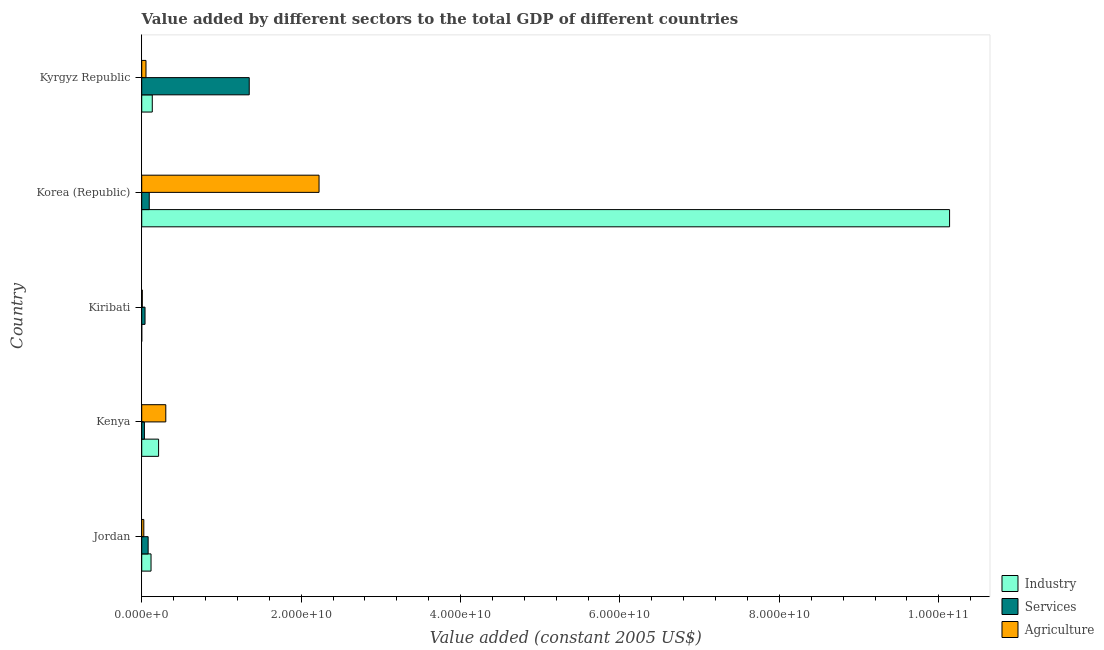How many different coloured bars are there?
Your answer should be compact. 3. How many groups of bars are there?
Keep it short and to the point. 5. How many bars are there on the 5th tick from the top?
Provide a short and direct response. 3. What is the label of the 2nd group of bars from the top?
Provide a short and direct response. Korea (Republic). What is the value added by industrial sector in Kiribati?
Your answer should be very brief. 3.87e+06. Across all countries, what is the maximum value added by industrial sector?
Offer a very short reply. 1.01e+11. Across all countries, what is the minimum value added by agricultural sector?
Give a very brief answer. 7.24e+07. In which country was the value added by industrial sector maximum?
Your answer should be compact. Korea (Republic). In which country was the value added by agricultural sector minimum?
Offer a very short reply. Kiribati. What is the total value added by industrial sector in the graph?
Offer a terse response. 1.06e+11. What is the difference between the value added by services in Kiribati and that in Kyrgyz Republic?
Provide a succinct answer. -1.31e+1. What is the difference between the value added by services in Korea (Republic) and the value added by industrial sector in Kiribati?
Offer a very short reply. 9.40e+08. What is the average value added by industrial sector per country?
Provide a succinct answer. 2.12e+1. What is the difference between the value added by services and value added by industrial sector in Kenya?
Offer a very short reply. -1.78e+09. In how many countries, is the value added by industrial sector greater than 52000000000 US$?
Your answer should be compact. 1. What is the ratio of the value added by services in Jordan to that in Kyrgyz Republic?
Ensure brevity in your answer.  0.06. What is the difference between the highest and the second highest value added by agricultural sector?
Your response must be concise. 1.92e+1. What is the difference between the highest and the lowest value added by industrial sector?
Keep it short and to the point. 1.01e+11. Is the sum of the value added by industrial sector in Korea (Republic) and Kyrgyz Republic greater than the maximum value added by services across all countries?
Your answer should be very brief. Yes. What does the 1st bar from the top in Jordan represents?
Make the answer very short. Agriculture. What does the 3rd bar from the bottom in Kiribati represents?
Provide a short and direct response. Agriculture. How many bars are there?
Give a very brief answer. 15. What is the difference between two consecutive major ticks on the X-axis?
Your response must be concise. 2.00e+1. Does the graph contain grids?
Make the answer very short. No. How are the legend labels stacked?
Give a very brief answer. Vertical. What is the title of the graph?
Offer a very short reply. Value added by different sectors to the total GDP of different countries. Does "Natural Gas" appear as one of the legend labels in the graph?
Give a very brief answer. No. What is the label or title of the X-axis?
Offer a terse response. Value added (constant 2005 US$). What is the label or title of the Y-axis?
Offer a terse response. Country. What is the Value added (constant 2005 US$) of Industry in Jordan?
Provide a succinct answer. 1.17e+09. What is the Value added (constant 2005 US$) of Services in Jordan?
Provide a succinct answer. 8.06e+08. What is the Value added (constant 2005 US$) of Agriculture in Jordan?
Make the answer very short. 2.62e+08. What is the Value added (constant 2005 US$) in Industry in Kenya?
Make the answer very short. 2.12e+09. What is the Value added (constant 2005 US$) in Services in Kenya?
Give a very brief answer. 3.37e+08. What is the Value added (constant 2005 US$) of Agriculture in Kenya?
Provide a succinct answer. 3.02e+09. What is the Value added (constant 2005 US$) of Industry in Kiribati?
Make the answer very short. 3.87e+06. What is the Value added (constant 2005 US$) in Services in Kiribati?
Provide a short and direct response. 4.15e+08. What is the Value added (constant 2005 US$) in Agriculture in Kiribati?
Offer a terse response. 7.24e+07. What is the Value added (constant 2005 US$) of Industry in Korea (Republic)?
Ensure brevity in your answer.  1.01e+11. What is the Value added (constant 2005 US$) of Services in Korea (Republic)?
Offer a terse response. 9.44e+08. What is the Value added (constant 2005 US$) of Agriculture in Korea (Republic)?
Make the answer very short. 2.22e+1. What is the Value added (constant 2005 US$) of Industry in Kyrgyz Republic?
Make the answer very short. 1.32e+09. What is the Value added (constant 2005 US$) in Services in Kyrgyz Republic?
Your response must be concise. 1.35e+1. What is the Value added (constant 2005 US$) in Agriculture in Kyrgyz Republic?
Ensure brevity in your answer.  5.34e+08. Across all countries, what is the maximum Value added (constant 2005 US$) in Industry?
Ensure brevity in your answer.  1.01e+11. Across all countries, what is the maximum Value added (constant 2005 US$) of Services?
Ensure brevity in your answer.  1.35e+1. Across all countries, what is the maximum Value added (constant 2005 US$) in Agriculture?
Your response must be concise. 2.22e+1. Across all countries, what is the minimum Value added (constant 2005 US$) of Industry?
Your response must be concise. 3.87e+06. Across all countries, what is the minimum Value added (constant 2005 US$) of Services?
Your answer should be compact. 3.37e+08. Across all countries, what is the minimum Value added (constant 2005 US$) of Agriculture?
Your response must be concise. 7.24e+07. What is the total Value added (constant 2005 US$) in Industry in the graph?
Offer a terse response. 1.06e+11. What is the total Value added (constant 2005 US$) of Services in the graph?
Your response must be concise. 1.60e+1. What is the total Value added (constant 2005 US$) in Agriculture in the graph?
Provide a succinct answer. 2.61e+1. What is the difference between the Value added (constant 2005 US$) in Industry in Jordan and that in Kenya?
Offer a terse response. -9.47e+08. What is the difference between the Value added (constant 2005 US$) of Services in Jordan and that in Kenya?
Make the answer very short. 4.69e+08. What is the difference between the Value added (constant 2005 US$) of Agriculture in Jordan and that in Kenya?
Provide a short and direct response. -2.76e+09. What is the difference between the Value added (constant 2005 US$) in Industry in Jordan and that in Kiribati?
Provide a short and direct response. 1.16e+09. What is the difference between the Value added (constant 2005 US$) in Services in Jordan and that in Kiribati?
Your answer should be very brief. 3.91e+08. What is the difference between the Value added (constant 2005 US$) in Agriculture in Jordan and that in Kiribati?
Give a very brief answer. 1.89e+08. What is the difference between the Value added (constant 2005 US$) of Industry in Jordan and that in Korea (Republic)?
Your answer should be compact. -1.00e+11. What is the difference between the Value added (constant 2005 US$) of Services in Jordan and that in Korea (Republic)?
Offer a very short reply. -1.38e+08. What is the difference between the Value added (constant 2005 US$) in Agriculture in Jordan and that in Korea (Republic)?
Your response must be concise. -2.20e+1. What is the difference between the Value added (constant 2005 US$) of Industry in Jordan and that in Kyrgyz Republic?
Offer a very short reply. -1.55e+08. What is the difference between the Value added (constant 2005 US$) of Services in Jordan and that in Kyrgyz Republic?
Give a very brief answer. -1.27e+1. What is the difference between the Value added (constant 2005 US$) of Agriculture in Jordan and that in Kyrgyz Republic?
Provide a short and direct response. -2.73e+08. What is the difference between the Value added (constant 2005 US$) in Industry in Kenya and that in Kiribati?
Offer a very short reply. 2.11e+09. What is the difference between the Value added (constant 2005 US$) in Services in Kenya and that in Kiribati?
Your answer should be very brief. -7.83e+07. What is the difference between the Value added (constant 2005 US$) of Agriculture in Kenya and that in Kiribati?
Give a very brief answer. 2.95e+09. What is the difference between the Value added (constant 2005 US$) in Industry in Kenya and that in Korea (Republic)?
Give a very brief answer. -9.92e+1. What is the difference between the Value added (constant 2005 US$) in Services in Kenya and that in Korea (Republic)?
Your response must be concise. -6.07e+08. What is the difference between the Value added (constant 2005 US$) in Agriculture in Kenya and that in Korea (Republic)?
Ensure brevity in your answer.  -1.92e+1. What is the difference between the Value added (constant 2005 US$) in Industry in Kenya and that in Kyrgyz Republic?
Make the answer very short. 7.92e+08. What is the difference between the Value added (constant 2005 US$) of Services in Kenya and that in Kyrgyz Republic?
Your answer should be very brief. -1.32e+1. What is the difference between the Value added (constant 2005 US$) of Agriculture in Kenya and that in Kyrgyz Republic?
Offer a terse response. 2.49e+09. What is the difference between the Value added (constant 2005 US$) of Industry in Kiribati and that in Korea (Republic)?
Offer a very short reply. -1.01e+11. What is the difference between the Value added (constant 2005 US$) in Services in Kiribati and that in Korea (Republic)?
Offer a very short reply. -5.29e+08. What is the difference between the Value added (constant 2005 US$) of Agriculture in Kiribati and that in Korea (Republic)?
Your response must be concise. -2.22e+1. What is the difference between the Value added (constant 2005 US$) of Industry in Kiribati and that in Kyrgyz Republic?
Offer a very short reply. -1.32e+09. What is the difference between the Value added (constant 2005 US$) of Services in Kiribati and that in Kyrgyz Republic?
Keep it short and to the point. -1.31e+1. What is the difference between the Value added (constant 2005 US$) in Agriculture in Kiribati and that in Kyrgyz Republic?
Provide a succinct answer. -4.62e+08. What is the difference between the Value added (constant 2005 US$) in Industry in Korea (Republic) and that in Kyrgyz Republic?
Provide a succinct answer. 1.00e+11. What is the difference between the Value added (constant 2005 US$) in Services in Korea (Republic) and that in Kyrgyz Republic?
Offer a very short reply. -1.25e+1. What is the difference between the Value added (constant 2005 US$) of Agriculture in Korea (Republic) and that in Kyrgyz Republic?
Offer a very short reply. 2.17e+1. What is the difference between the Value added (constant 2005 US$) in Industry in Jordan and the Value added (constant 2005 US$) in Services in Kenya?
Give a very brief answer. 8.32e+08. What is the difference between the Value added (constant 2005 US$) of Industry in Jordan and the Value added (constant 2005 US$) of Agriculture in Kenya?
Your answer should be very brief. -1.85e+09. What is the difference between the Value added (constant 2005 US$) in Services in Jordan and the Value added (constant 2005 US$) in Agriculture in Kenya?
Make the answer very short. -2.21e+09. What is the difference between the Value added (constant 2005 US$) of Industry in Jordan and the Value added (constant 2005 US$) of Services in Kiribati?
Your answer should be very brief. 7.54e+08. What is the difference between the Value added (constant 2005 US$) in Industry in Jordan and the Value added (constant 2005 US$) in Agriculture in Kiribati?
Your answer should be very brief. 1.10e+09. What is the difference between the Value added (constant 2005 US$) of Services in Jordan and the Value added (constant 2005 US$) of Agriculture in Kiribati?
Offer a very short reply. 7.33e+08. What is the difference between the Value added (constant 2005 US$) in Industry in Jordan and the Value added (constant 2005 US$) in Services in Korea (Republic)?
Your answer should be very brief. 2.25e+08. What is the difference between the Value added (constant 2005 US$) of Industry in Jordan and the Value added (constant 2005 US$) of Agriculture in Korea (Republic)?
Your answer should be compact. -2.11e+1. What is the difference between the Value added (constant 2005 US$) of Services in Jordan and the Value added (constant 2005 US$) of Agriculture in Korea (Republic)?
Offer a terse response. -2.14e+1. What is the difference between the Value added (constant 2005 US$) in Industry in Jordan and the Value added (constant 2005 US$) in Services in Kyrgyz Republic?
Offer a terse response. -1.23e+1. What is the difference between the Value added (constant 2005 US$) of Industry in Jordan and the Value added (constant 2005 US$) of Agriculture in Kyrgyz Republic?
Keep it short and to the point. 6.34e+08. What is the difference between the Value added (constant 2005 US$) in Services in Jordan and the Value added (constant 2005 US$) in Agriculture in Kyrgyz Republic?
Make the answer very short. 2.71e+08. What is the difference between the Value added (constant 2005 US$) of Industry in Kenya and the Value added (constant 2005 US$) of Services in Kiribati?
Provide a succinct answer. 1.70e+09. What is the difference between the Value added (constant 2005 US$) of Industry in Kenya and the Value added (constant 2005 US$) of Agriculture in Kiribati?
Offer a very short reply. 2.04e+09. What is the difference between the Value added (constant 2005 US$) in Services in Kenya and the Value added (constant 2005 US$) in Agriculture in Kiribati?
Give a very brief answer. 2.64e+08. What is the difference between the Value added (constant 2005 US$) of Industry in Kenya and the Value added (constant 2005 US$) of Services in Korea (Republic)?
Provide a short and direct response. 1.17e+09. What is the difference between the Value added (constant 2005 US$) in Industry in Kenya and the Value added (constant 2005 US$) in Agriculture in Korea (Republic)?
Provide a succinct answer. -2.01e+1. What is the difference between the Value added (constant 2005 US$) of Services in Kenya and the Value added (constant 2005 US$) of Agriculture in Korea (Republic)?
Make the answer very short. -2.19e+1. What is the difference between the Value added (constant 2005 US$) of Industry in Kenya and the Value added (constant 2005 US$) of Services in Kyrgyz Republic?
Offer a very short reply. -1.14e+1. What is the difference between the Value added (constant 2005 US$) of Industry in Kenya and the Value added (constant 2005 US$) of Agriculture in Kyrgyz Republic?
Ensure brevity in your answer.  1.58e+09. What is the difference between the Value added (constant 2005 US$) of Services in Kenya and the Value added (constant 2005 US$) of Agriculture in Kyrgyz Republic?
Your response must be concise. -1.98e+08. What is the difference between the Value added (constant 2005 US$) in Industry in Kiribati and the Value added (constant 2005 US$) in Services in Korea (Republic)?
Offer a very short reply. -9.40e+08. What is the difference between the Value added (constant 2005 US$) of Industry in Kiribati and the Value added (constant 2005 US$) of Agriculture in Korea (Republic)?
Make the answer very short. -2.22e+1. What is the difference between the Value added (constant 2005 US$) of Services in Kiribati and the Value added (constant 2005 US$) of Agriculture in Korea (Republic)?
Your answer should be very brief. -2.18e+1. What is the difference between the Value added (constant 2005 US$) in Industry in Kiribati and the Value added (constant 2005 US$) in Services in Kyrgyz Republic?
Give a very brief answer. -1.35e+1. What is the difference between the Value added (constant 2005 US$) in Industry in Kiribati and the Value added (constant 2005 US$) in Agriculture in Kyrgyz Republic?
Offer a very short reply. -5.30e+08. What is the difference between the Value added (constant 2005 US$) of Services in Kiribati and the Value added (constant 2005 US$) of Agriculture in Kyrgyz Republic?
Provide a short and direct response. -1.19e+08. What is the difference between the Value added (constant 2005 US$) in Industry in Korea (Republic) and the Value added (constant 2005 US$) in Services in Kyrgyz Republic?
Your answer should be compact. 8.79e+1. What is the difference between the Value added (constant 2005 US$) in Industry in Korea (Republic) and the Value added (constant 2005 US$) in Agriculture in Kyrgyz Republic?
Give a very brief answer. 1.01e+11. What is the difference between the Value added (constant 2005 US$) of Services in Korea (Republic) and the Value added (constant 2005 US$) of Agriculture in Kyrgyz Republic?
Your answer should be very brief. 4.09e+08. What is the average Value added (constant 2005 US$) in Industry per country?
Give a very brief answer. 2.12e+1. What is the average Value added (constant 2005 US$) in Services per country?
Your answer should be compact. 3.20e+09. What is the average Value added (constant 2005 US$) of Agriculture per country?
Offer a very short reply. 5.23e+09. What is the difference between the Value added (constant 2005 US$) of Industry and Value added (constant 2005 US$) of Services in Jordan?
Give a very brief answer. 3.63e+08. What is the difference between the Value added (constant 2005 US$) in Industry and Value added (constant 2005 US$) in Agriculture in Jordan?
Make the answer very short. 9.07e+08. What is the difference between the Value added (constant 2005 US$) of Services and Value added (constant 2005 US$) of Agriculture in Jordan?
Your response must be concise. 5.44e+08. What is the difference between the Value added (constant 2005 US$) in Industry and Value added (constant 2005 US$) in Services in Kenya?
Offer a terse response. 1.78e+09. What is the difference between the Value added (constant 2005 US$) in Industry and Value added (constant 2005 US$) in Agriculture in Kenya?
Your answer should be compact. -9.04e+08. What is the difference between the Value added (constant 2005 US$) of Services and Value added (constant 2005 US$) of Agriculture in Kenya?
Provide a succinct answer. -2.68e+09. What is the difference between the Value added (constant 2005 US$) of Industry and Value added (constant 2005 US$) of Services in Kiribati?
Your answer should be compact. -4.11e+08. What is the difference between the Value added (constant 2005 US$) of Industry and Value added (constant 2005 US$) of Agriculture in Kiribati?
Provide a short and direct response. -6.85e+07. What is the difference between the Value added (constant 2005 US$) in Services and Value added (constant 2005 US$) in Agriculture in Kiribati?
Keep it short and to the point. 3.43e+08. What is the difference between the Value added (constant 2005 US$) in Industry and Value added (constant 2005 US$) in Services in Korea (Republic)?
Provide a short and direct response. 1.00e+11. What is the difference between the Value added (constant 2005 US$) of Industry and Value added (constant 2005 US$) of Agriculture in Korea (Republic)?
Your answer should be compact. 7.91e+1. What is the difference between the Value added (constant 2005 US$) of Services and Value added (constant 2005 US$) of Agriculture in Korea (Republic)?
Keep it short and to the point. -2.13e+1. What is the difference between the Value added (constant 2005 US$) in Industry and Value added (constant 2005 US$) in Services in Kyrgyz Republic?
Offer a very short reply. -1.22e+1. What is the difference between the Value added (constant 2005 US$) in Industry and Value added (constant 2005 US$) in Agriculture in Kyrgyz Republic?
Your answer should be compact. 7.90e+08. What is the difference between the Value added (constant 2005 US$) of Services and Value added (constant 2005 US$) of Agriculture in Kyrgyz Republic?
Keep it short and to the point. 1.30e+1. What is the ratio of the Value added (constant 2005 US$) of Industry in Jordan to that in Kenya?
Provide a short and direct response. 0.55. What is the ratio of the Value added (constant 2005 US$) in Services in Jordan to that in Kenya?
Make the answer very short. 2.39. What is the ratio of the Value added (constant 2005 US$) of Agriculture in Jordan to that in Kenya?
Your answer should be compact. 0.09. What is the ratio of the Value added (constant 2005 US$) of Industry in Jordan to that in Kiribati?
Ensure brevity in your answer.  302.11. What is the ratio of the Value added (constant 2005 US$) of Services in Jordan to that in Kiribati?
Offer a terse response. 1.94. What is the ratio of the Value added (constant 2005 US$) of Agriculture in Jordan to that in Kiribati?
Keep it short and to the point. 3.61. What is the ratio of the Value added (constant 2005 US$) in Industry in Jordan to that in Korea (Republic)?
Keep it short and to the point. 0.01. What is the ratio of the Value added (constant 2005 US$) in Services in Jordan to that in Korea (Republic)?
Keep it short and to the point. 0.85. What is the ratio of the Value added (constant 2005 US$) of Agriculture in Jordan to that in Korea (Republic)?
Make the answer very short. 0.01. What is the ratio of the Value added (constant 2005 US$) of Industry in Jordan to that in Kyrgyz Republic?
Make the answer very short. 0.88. What is the ratio of the Value added (constant 2005 US$) of Services in Jordan to that in Kyrgyz Republic?
Offer a very short reply. 0.06. What is the ratio of the Value added (constant 2005 US$) of Agriculture in Jordan to that in Kyrgyz Republic?
Your response must be concise. 0.49. What is the ratio of the Value added (constant 2005 US$) of Industry in Kenya to that in Kiribati?
Offer a terse response. 546.99. What is the ratio of the Value added (constant 2005 US$) in Services in Kenya to that in Kiribati?
Keep it short and to the point. 0.81. What is the ratio of the Value added (constant 2005 US$) of Agriculture in Kenya to that in Kiribati?
Your answer should be compact. 41.73. What is the ratio of the Value added (constant 2005 US$) of Industry in Kenya to that in Korea (Republic)?
Provide a short and direct response. 0.02. What is the ratio of the Value added (constant 2005 US$) in Services in Kenya to that in Korea (Republic)?
Your response must be concise. 0.36. What is the ratio of the Value added (constant 2005 US$) of Agriculture in Kenya to that in Korea (Republic)?
Give a very brief answer. 0.14. What is the ratio of the Value added (constant 2005 US$) of Industry in Kenya to that in Kyrgyz Republic?
Keep it short and to the point. 1.6. What is the ratio of the Value added (constant 2005 US$) in Services in Kenya to that in Kyrgyz Republic?
Your answer should be very brief. 0.03. What is the ratio of the Value added (constant 2005 US$) in Agriculture in Kenya to that in Kyrgyz Republic?
Offer a terse response. 5.65. What is the ratio of the Value added (constant 2005 US$) in Services in Kiribati to that in Korea (Republic)?
Ensure brevity in your answer.  0.44. What is the ratio of the Value added (constant 2005 US$) in Agriculture in Kiribati to that in Korea (Republic)?
Keep it short and to the point. 0. What is the ratio of the Value added (constant 2005 US$) of Industry in Kiribati to that in Kyrgyz Republic?
Keep it short and to the point. 0. What is the ratio of the Value added (constant 2005 US$) of Services in Kiribati to that in Kyrgyz Republic?
Your answer should be very brief. 0.03. What is the ratio of the Value added (constant 2005 US$) of Agriculture in Kiribati to that in Kyrgyz Republic?
Your response must be concise. 0.14. What is the ratio of the Value added (constant 2005 US$) of Industry in Korea (Republic) to that in Kyrgyz Republic?
Keep it short and to the point. 76.54. What is the ratio of the Value added (constant 2005 US$) in Services in Korea (Republic) to that in Kyrgyz Republic?
Offer a very short reply. 0.07. What is the ratio of the Value added (constant 2005 US$) of Agriculture in Korea (Republic) to that in Kyrgyz Republic?
Give a very brief answer. 41.64. What is the difference between the highest and the second highest Value added (constant 2005 US$) of Industry?
Ensure brevity in your answer.  9.92e+1. What is the difference between the highest and the second highest Value added (constant 2005 US$) of Services?
Make the answer very short. 1.25e+1. What is the difference between the highest and the second highest Value added (constant 2005 US$) in Agriculture?
Your answer should be compact. 1.92e+1. What is the difference between the highest and the lowest Value added (constant 2005 US$) of Industry?
Your response must be concise. 1.01e+11. What is the difference between the highest and the lowest Value added (constant 2005 US$) of Services?
Provide a succinct answer. 1.32e+1. What is the difference between the highest and the lowest Value added (constant 2005 US$) of Agriculture?
Your answer should be very brief. 2.22e+1. 